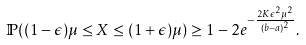Convert formula to latex. <formula><loc_0><loc_0><loc_500><loc_500>\mathbb { P } ( ( 1 - \epsilon ) \mu \leq X \leq ( 1 + \epsilon ) \mu ) & \geq 1 - 2 e ^ { - \frac { 2 K \epsilon ^ { 2 } \mu ^ { 2 } } { ( b - a ) ^ { 2 } } } .</formula> 